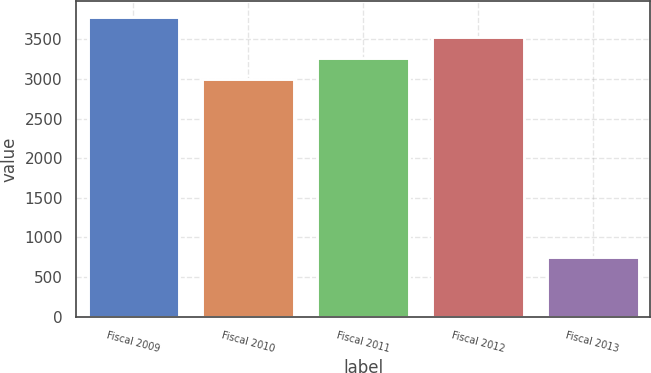Convert chart to OTSL. <chart><loc_0><loc_0><loc_500><loc_500><bar_chart><fcel>Fiscal 2009<fcel>Fiscal 2010<fcel>Fiscal 2011<fcel>Fiscal 2012<fcel>Fiscal 2013<nl><fcel>3786.3<fcel>3000<fcel>3262.1<fcel>3524.2<fcel>750<nl></chart> 